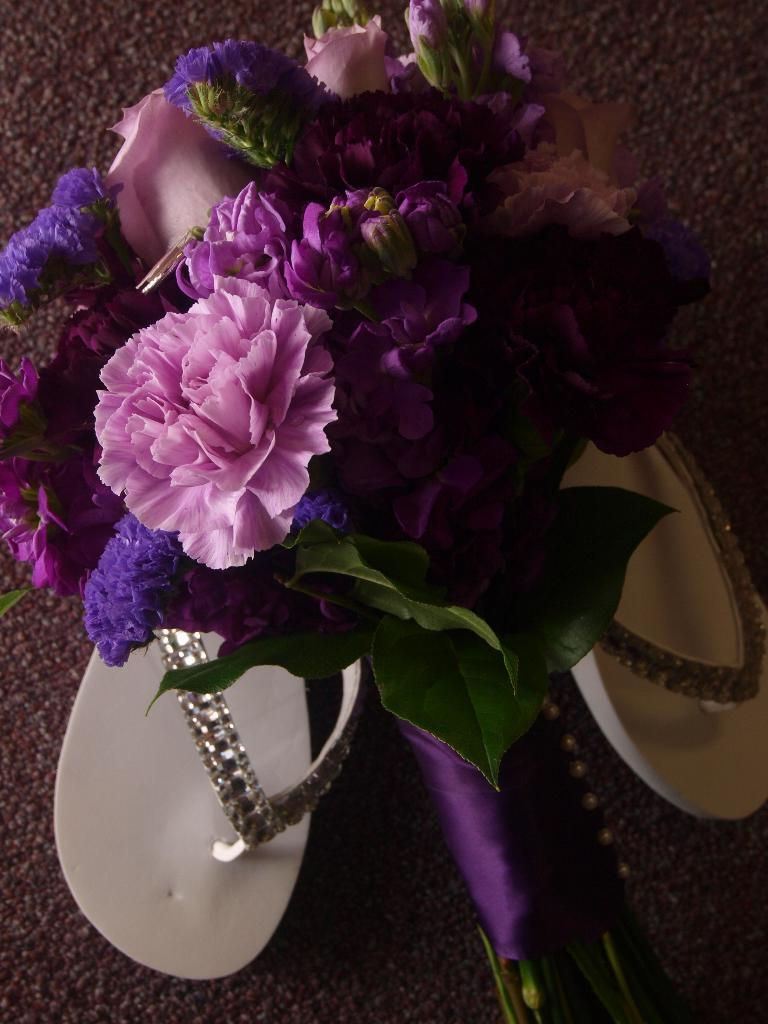What can be seen in the image that represents flowers or plants? There is a bouquet in the image. What type of accessory for the feet is visible in the image? There is footwear in the image. How does the needle roll across the floor in the image? There is no needle present in the image, so it cannot roll across the floor. 